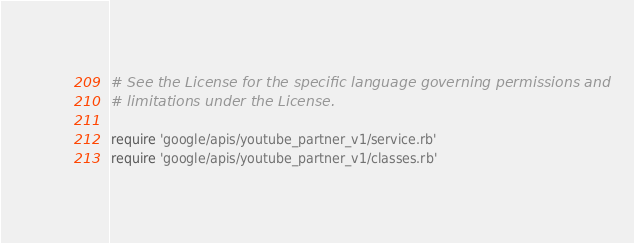<code> <loc_0><loc_0><loc_500><loc_500><_Ruby_># See the License for the specific language governing permissions and
# limitations under the License.

require 'google/apis/youtube_partner_v1/service.rb'
require 'google/apis/youtube_partner_v1/classes.rb'</code> 